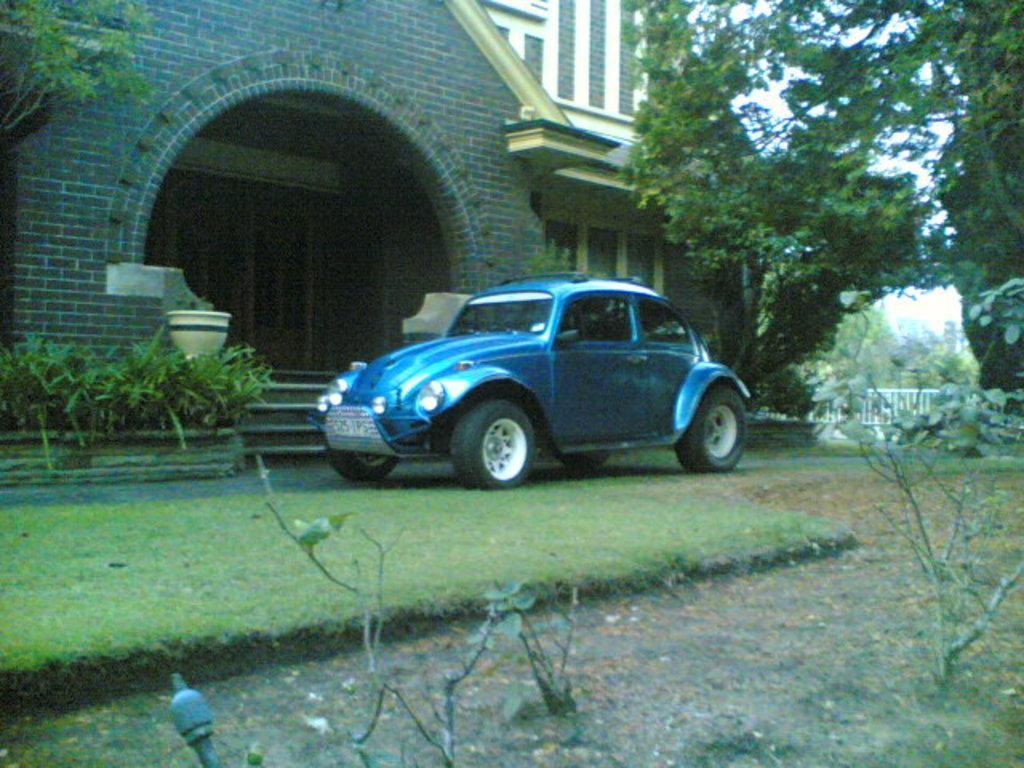Could you give a brief overview of what you see in this image? In the image there is a blue color on the land with garden,plants and trees around it, in the back there is a building. 